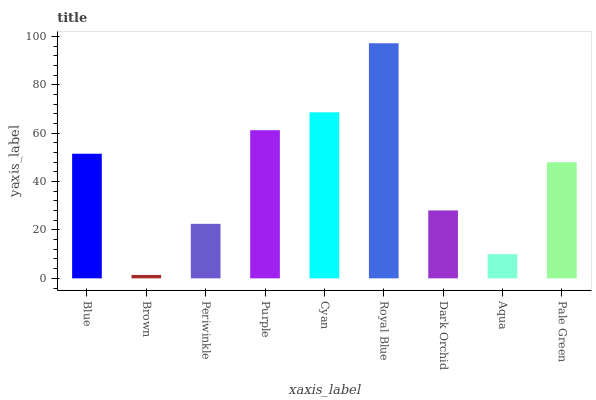Is Brown the minimum?
Answer yes or no. Yes. Is Royal Blue the maximum?
Answer yes or no. Yes. Is Periwinkle the minimum?
Answer yes or no. No. Is Periwinkle the maximum?
Answer yes or no. No. Is Periwinkle greater than Brown?
Answer yes or no. Yes. Is Brown less than Periwinkle?
Answer yes or no. Yes. Is Brown greater than Periwinkle?
Answer yes or no. No. Is Periwinkle less than Brown?
Answer yes or no. No. Is Pale Green the high median?
Answer yes or no. Yes. Is Pale Green the low median?
Answer yes or no. Yes. Is Royal Blue the high median?
Answer yes or no. No. Is Aqua the low median?
Answer yes or no. No. 